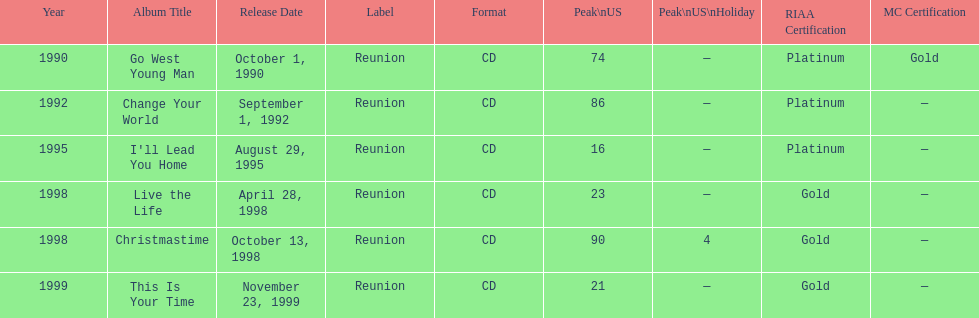Riaa: gold is only one of the certifications, but what is the other? Platinum. 